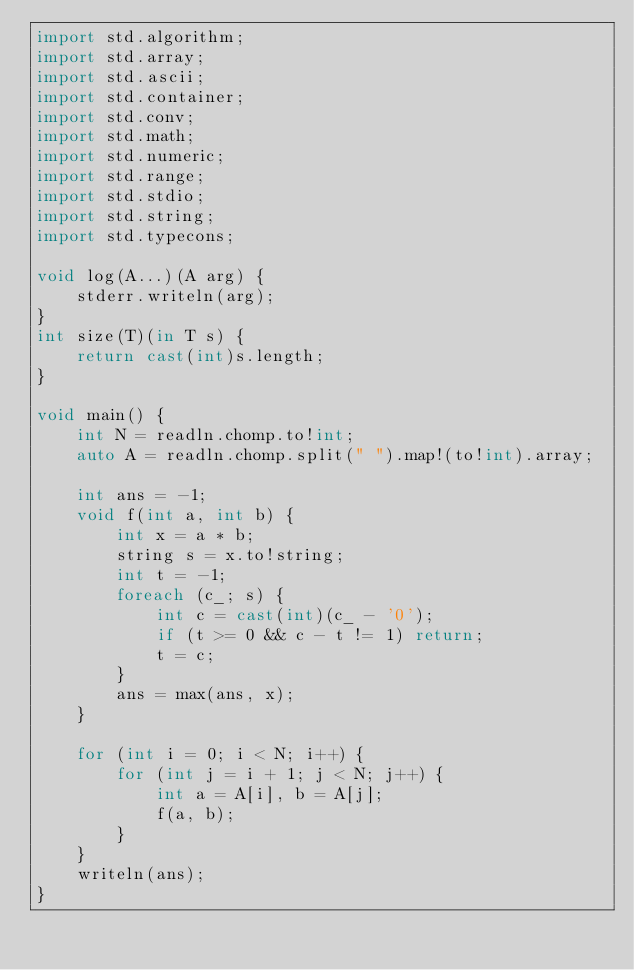Convert code to text. <code><loc_0><loc_0><loc_500><loc_500><_D_>import std.algorithm;
import std.array;
import std.ascii;
import std.container;
import std.conv;
import std.math;
import std.numeric;
import std.range;
import std.stdio;
import std.string;
import std.typecons;

void log(A...)(A arg) {
    stderr.writeln(arg);
}
int size(T)(in T s) {
    return cast(int)s.length;
}

void main() {
    int N = readln.chomp.to!int;
    auto A = readln.chomp.split(" ").map!(to!int).array;

    int ans = -1;
    void f(int a, int b) {
        int x = a * b;
        string s = x.to!string;
        int t = -1;
        foreach (c_; s) {
            int c = cast(int)(c_ - '0');
            if (t >= 0 && c - t != 1) return;
            t = c;
        }
        ans = max(ans, x);
    }

    for (int i = 0; i < N; i++) {
        for (int j = i + 1; j < N; j++) {
            int a = A[i], b = A[j];
            f(a, b);
        }
    }
    writeln(ans);
}</code> 